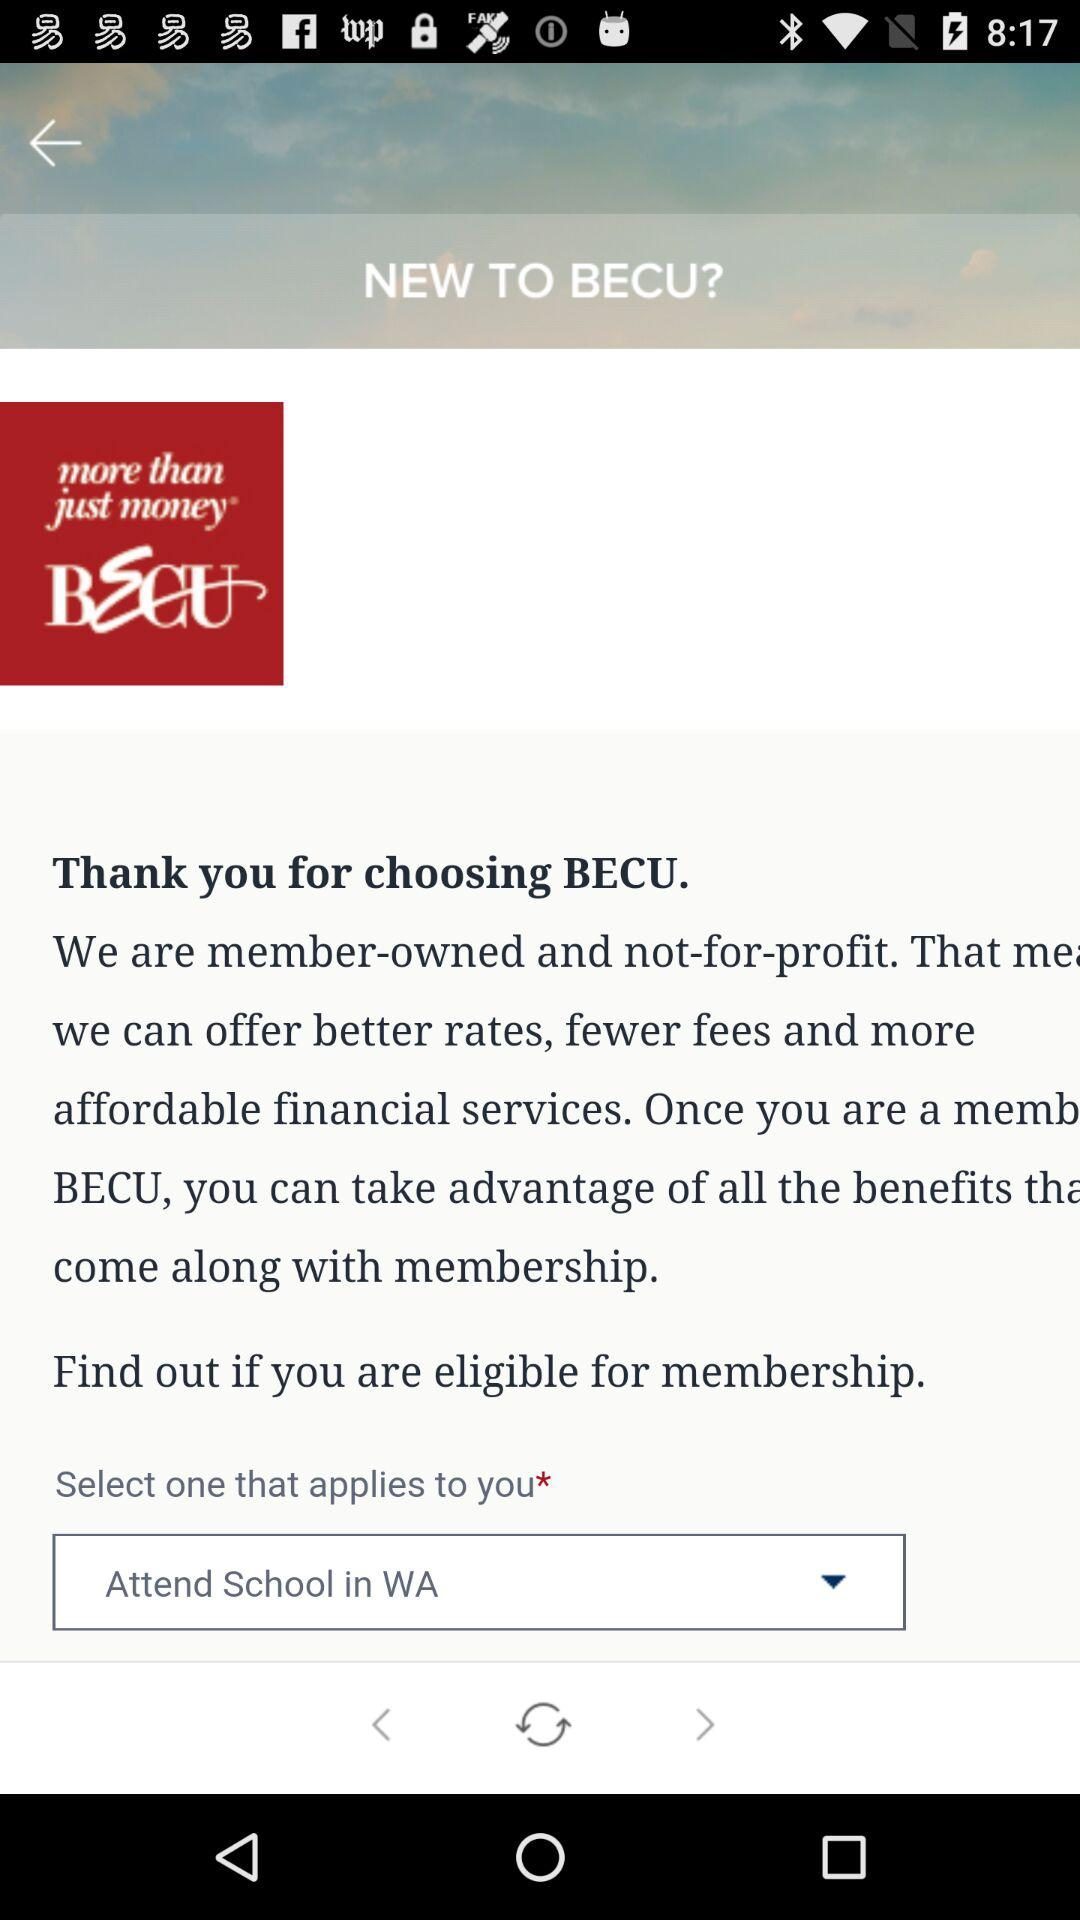Which option is selected? The selected option is "Attend School in WA". 